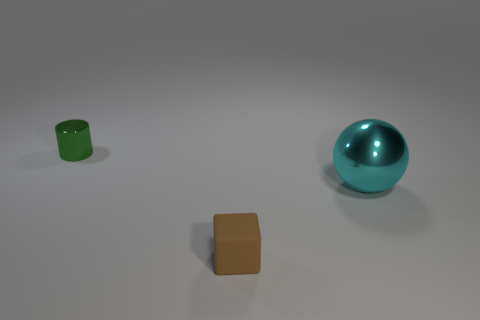Add 1 red matte things. How many objects exist? 4 Subtract all blocks. How many objects are left? 2 Add 3 cylinders. How many cylinders are left? 4 Add 3 large spheres. How many large spheres exist? 4 Subtract 0 yellow balls. How many objects are left? 3 Subtract all small brown rubber cubes. Subtract all big cyan spheres. How many objects are left? 1 